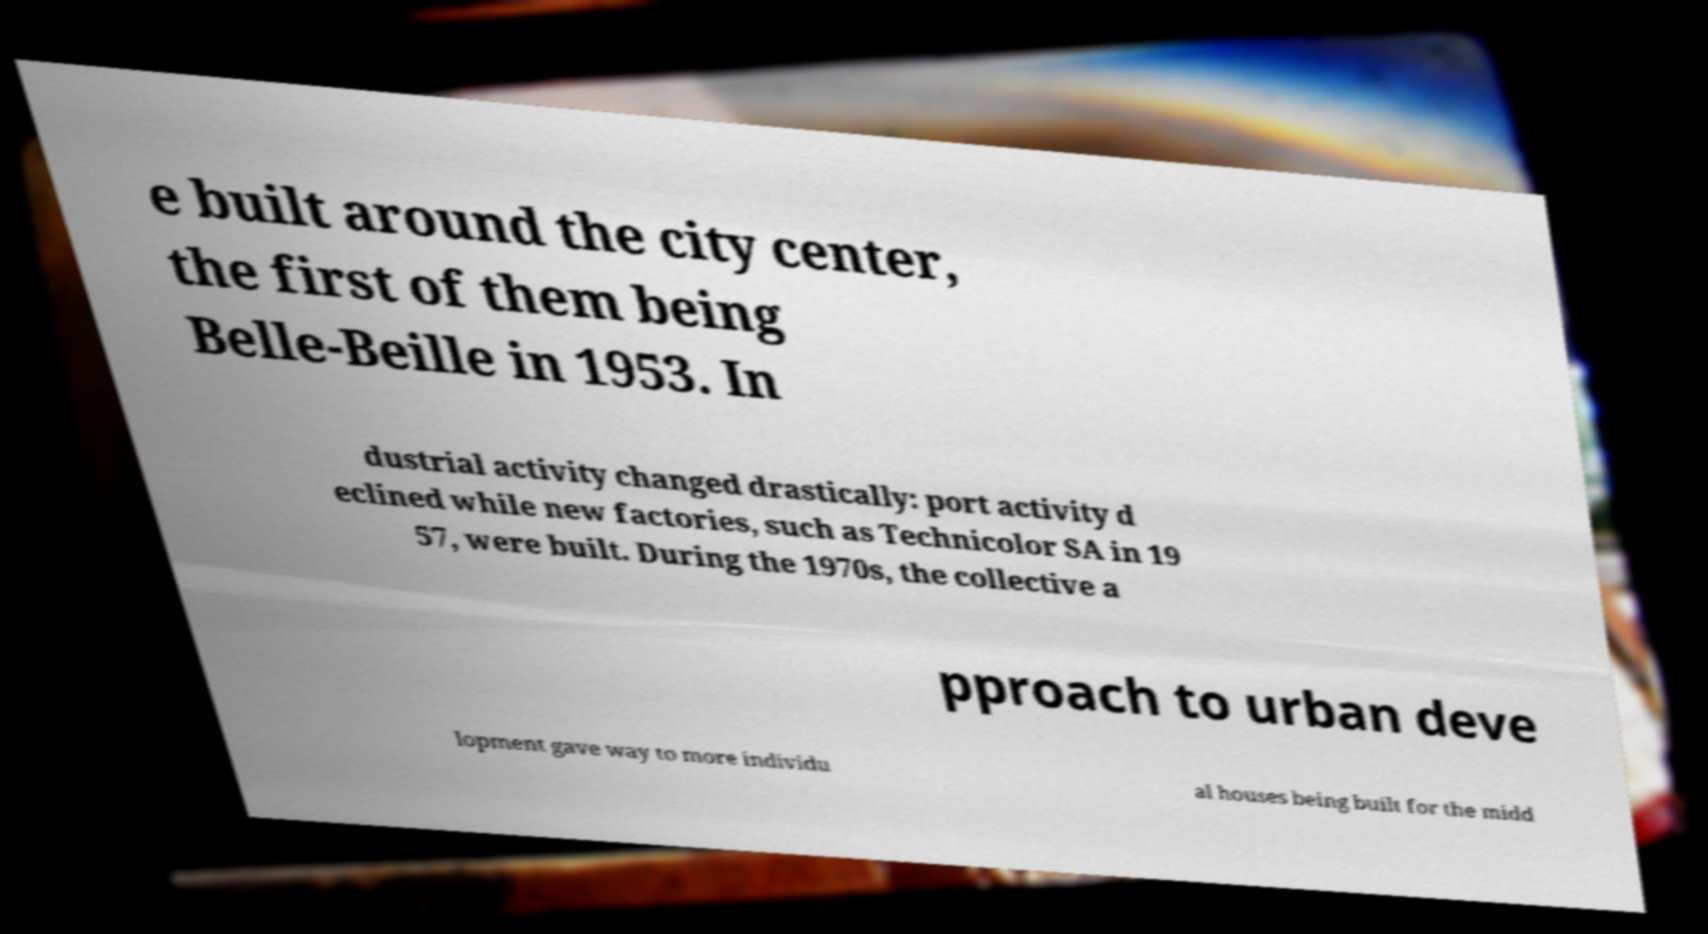For documentation purposes, I need the text within this image transcribed. Could you provide that? e built around the city center, the first of them being Belle-Beille in 1953. In dustrial activity changed drastically: port activity d eclined while new factories, such as Technicolor SA in 19 57, were built. During the 1970s, the collective a pproach to urban deve lopment gave way to more individu al houses being built for the midd 